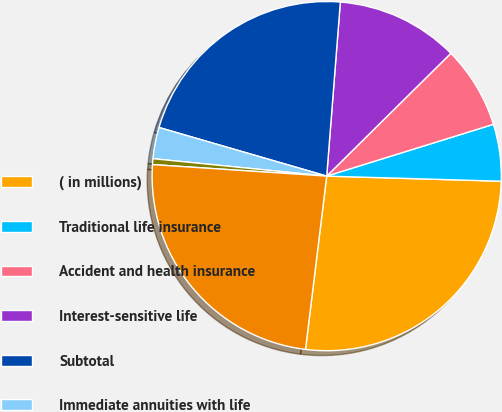Convert chart to OTSL. <chart><loc_0><loc_0><loc_500><loc_500><pie_chart><fcel>( in millions)<fcel>Traditional life insurance<fcel>Accident and health insurance<fcel>Interest-sensitive life<fcel>Subtotal<fcel>Immediate annuities with life<fcel>Other fixed annuity contract<fcel>Life and annuity premiums and<nl><fcel>26.47%<fcel>5.26%<fcel>7.62%<fcel>11.34%<fcel>21.75%<fcel>2.9%<fcel>0.54%<fcel>24.11%<nl></chart> 